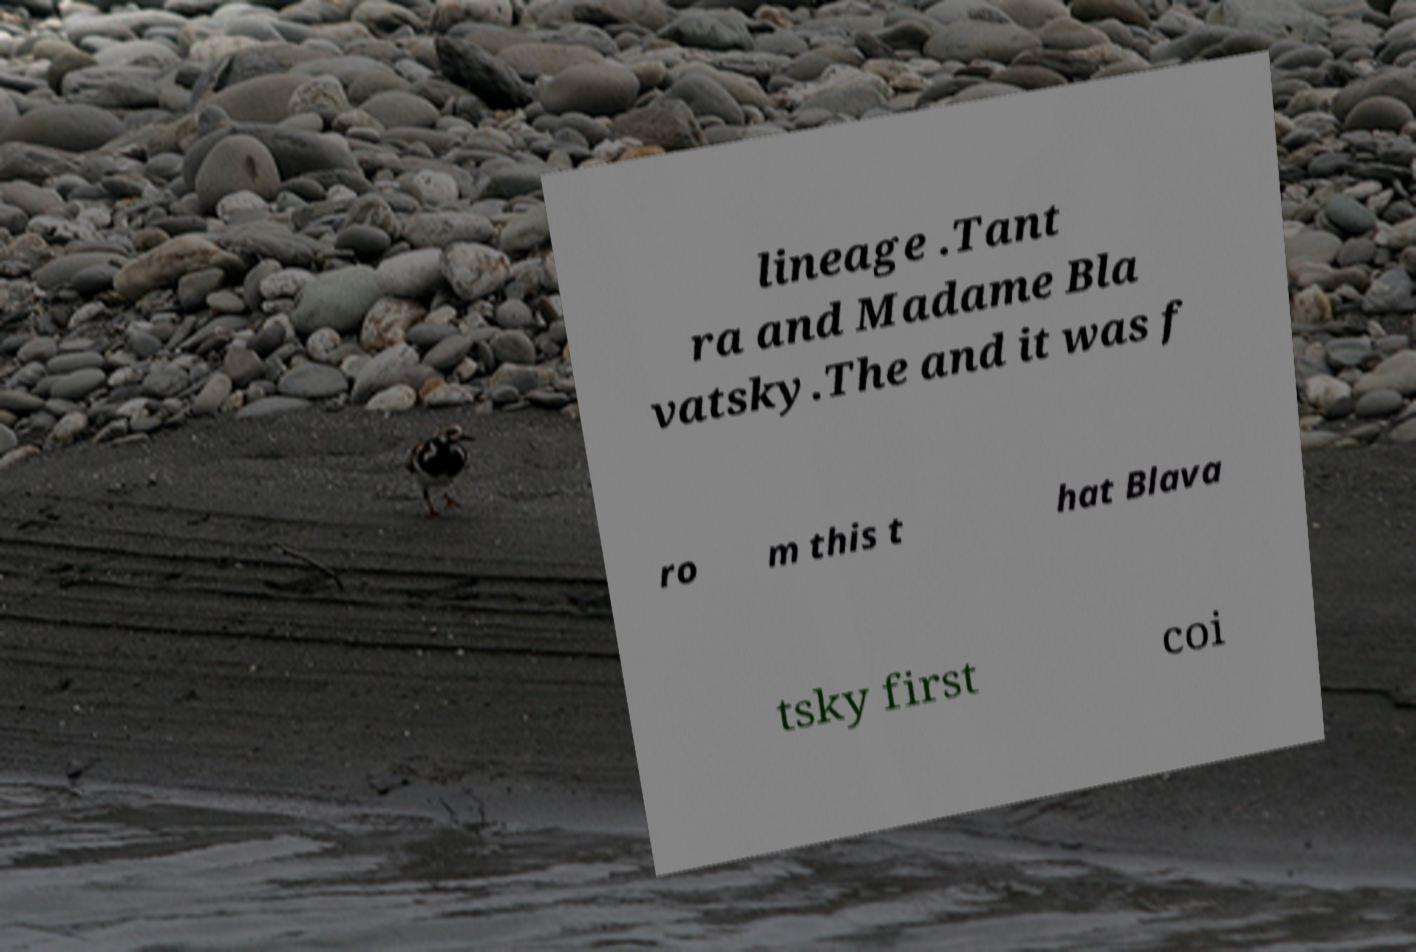Can you read and provide the text displayed in the image?This photo seems to have some interesting text. Can you extract and type it out for me? lineage .Tant ra and Madame Bla vatsky.The and it was f ro m this t hat Blava tsky first coi 